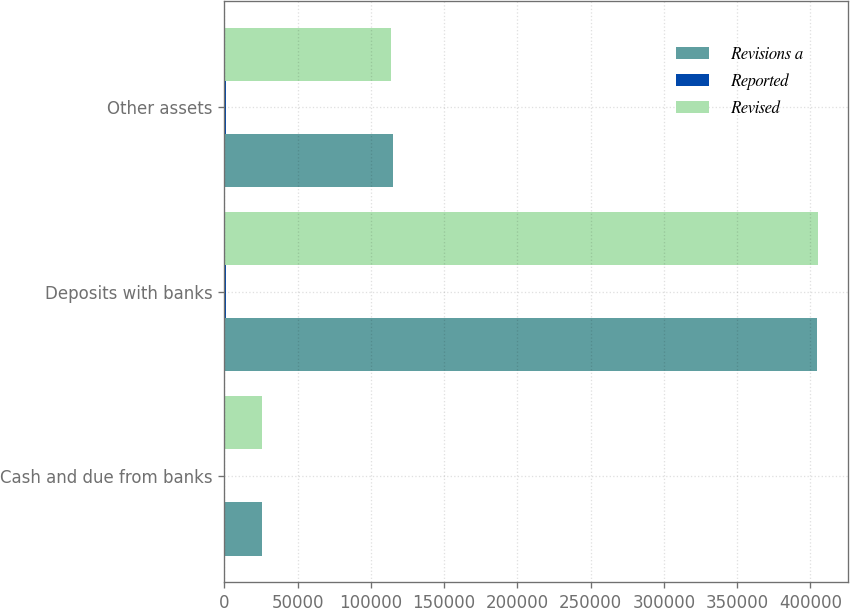Convert chart to OTSL. <chart><loc_0><loc_0><loc_500><loc_500><stacked_bar_chart><ecel><fcel>Cash and due from banks<fcel>Deposits with banks<fcel>Other assets<nl><fcel>Revisions a<fcel>25827<fcel>404294<fcel>114770<nl><fcel>Reported<fcel>71<fcel>1112<fcel>1183<nl><fcel>Revised<fcel>25898<fcel>405406<fcel>113587<nl></chart> 